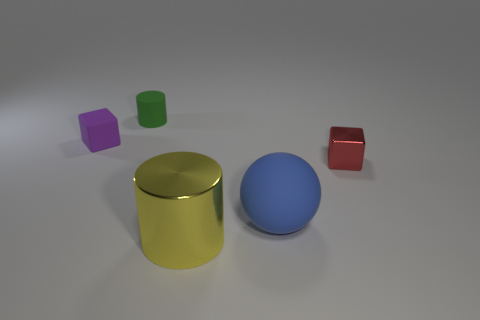Add 5 rubber spheres. How many objects exist? 10 Subtract all small green metallic balls. Subtract all tiny purple matte blocks. How many objects are left? 4 Add 2 small red shiny things. How many small red shiny things are left? 3 Add 3 blocks. How many blocks exist? 5 Subtract 0 yellow spheres. How many objects are left? 5 Subtract all balls. How many objects are left? 4 